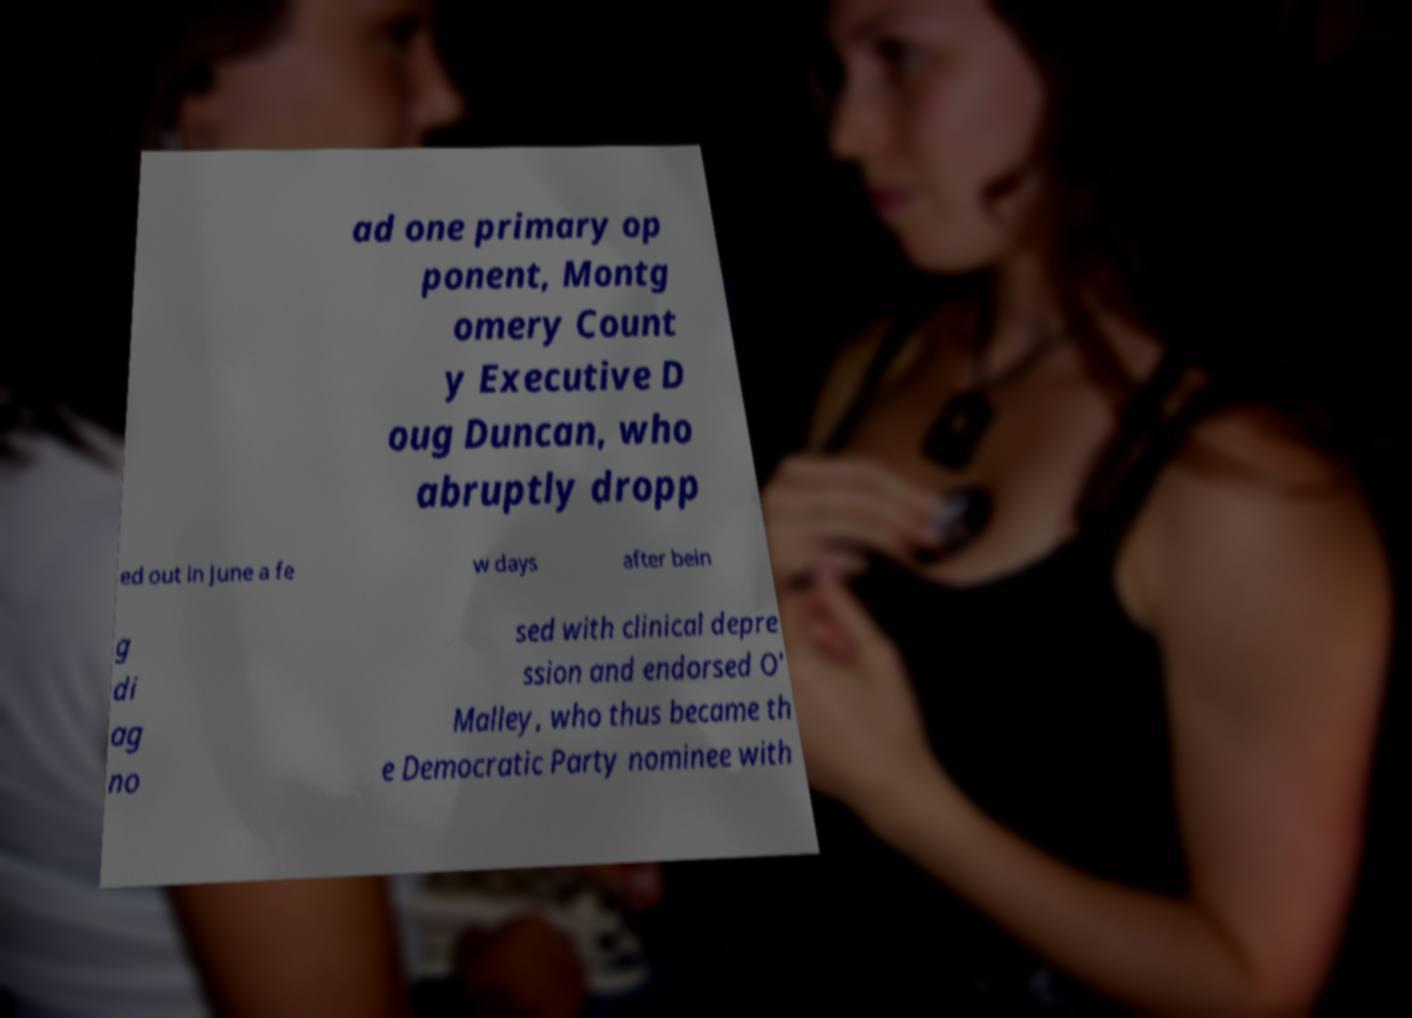Please read and relay the text visible in this image. What does it say? ad one primary op ponent, Montg omery Count y Executive D oug Duncan, who abruptly dropp ed out in June a fe w days after bein g di ag no sed with clinical depre ssion and endorsed O' Malley, who thus became th e Democratic Party nominee with 